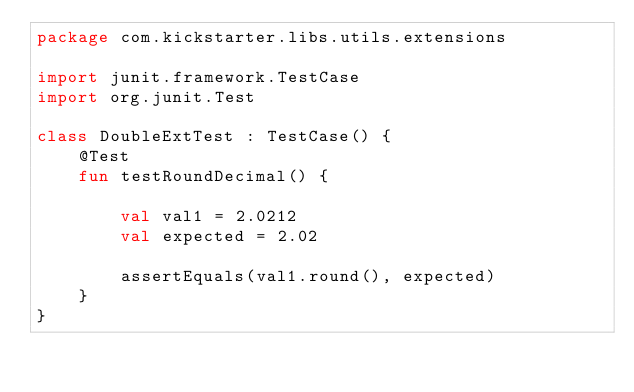<code> <loc_0><loc_0><loc_500><loc_500><_Kotlin_>package com.kickstarter.libs.utils.extensions

import junit.framework.TestCase
import org.junit.Test

class DoubleExtTest : TestCase() {
    @Test
    fun testRoundDecimal() {

        val val1 = 2.0212
        val expected = 2.02

        assertEquals(val1.round(), expected)
    }
}
</code> 